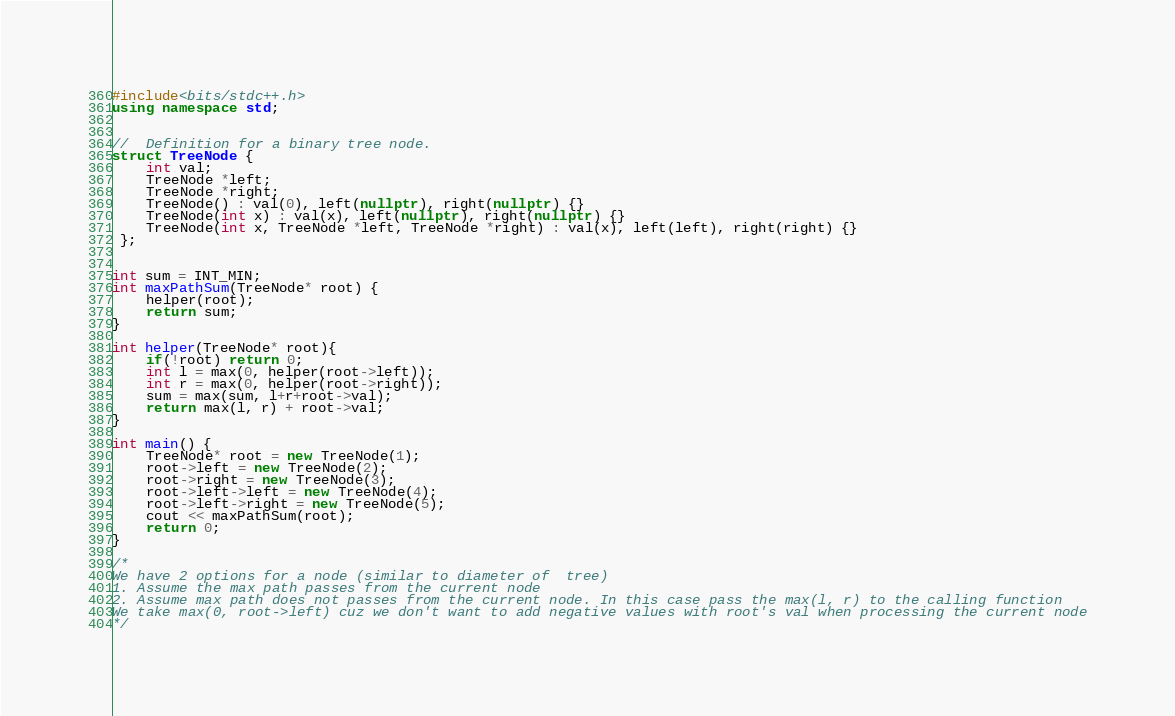Convert code to text. <code><loc_0><loc_0><loc_500><loc_500><_C++_>#include<bits/stdc++.h>
using namespace std;


//  Definition for a binary tree node.
struct TreeNode {
    int val;
    TreeNode *left;
    TreeNode *right;
    TreeNode() : val(0), left(nullptr), right(nullptr) {}
    TreeNode(int x) : val(x), left(nullptr), right(nullptr) {}
    TreeNode(int x, TreeNode *left, TreeNode *right) : val(x), left(left), right(right) {}
 };
 

int sum = INT_MIN;
int maxPathSum(TreeNode* root) {
    helper(root);
    return sum;
}

int helper(TreeNode* root){
    if(!root) return 0;
    int l = max(0, helper(root->left)); 
    int r = max(0, helper(root->right));
    sum = max(sum, l+r+root->val);
    return max(l, r) + root->val;
}

int main() {
    TreeNode* root = new TreeNode(1);
    root->left = new TreeNode(2);
    root->right = new TreeNode(3);
    root->left->left = new TreeNode(4);
    root->left->right = new TreeNode(5);
    cout << maxPathSum(root);
    return 0;
}

/*
We have 2 options for a node (similar to diameter of  tree)
1. Assume the max path passes from the current node
2. Assume max path does not passes from the current node. In this case pass the max(l, r) to the calling function
We take max(0, root->left) cuz we don't want to add negative values with root's val when processing the current node
*/</code> 